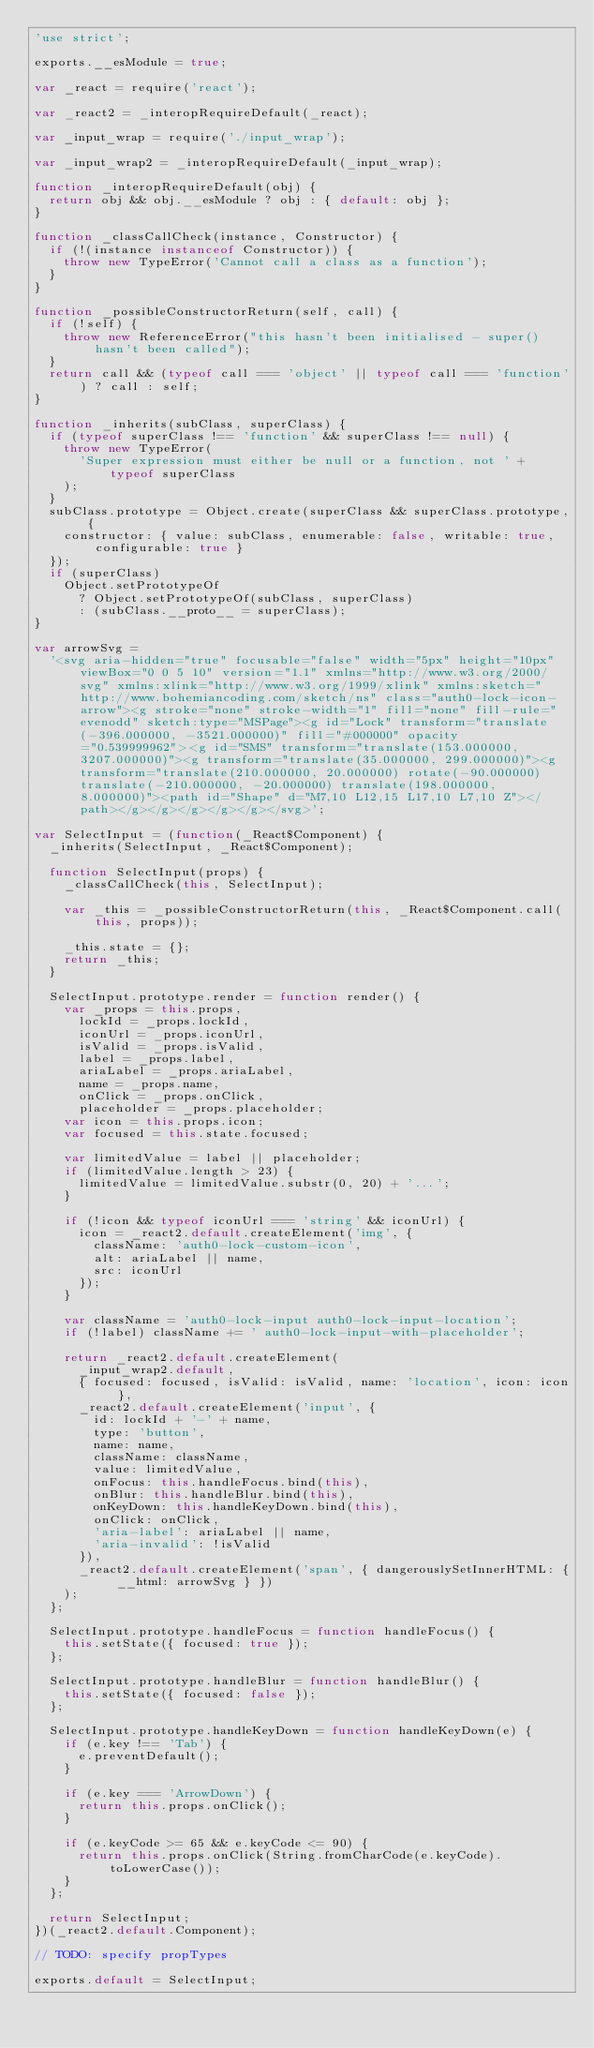Convert code to text. <code><loc_0><loc_0><loc_500><loc_500><_JavaScript_>'use strict';

exports.__esModule = true;

var _react = require('react');

var _react2 = _interopRequireDefault(_react);

var _input_wrap = require('./input_wrap');

var _input_wrap2 = _interopRequireDefault(_input_wrap);

function _interopRequireDefault(obj) {
  return obj && obj.__esModule ? obj : { default: obj };
}

function _classCallCheck(instance, Constructor) {
  if (!(instance instanceof Constructor)) {
    throw new TypeError('Cannot call a class as a function');
  }
}

function _possibleConstructorReturn(self, call) {
  if (!self) {
    throw new ReferenceError("this hasn't been initialised - super() hasn't been called");
  }
  return call && (typeof call === 'object' || typeof call === 'function') ? call : self;
}

function _inherits(subClass, superClass) {
  if (typeof superClass !== 'function' && superClass !== null) {
    throw new TypeError(
      'Super expression must either be null or a function, not ' + typeof superClass
    );
  }
  subClass.prototype = Object.create(superClass && superClass.prototype, {
    constructor: { value: subClass, enumerable: false, writable: true, configurable: true }
  });
  if (superClass)
    Object.setPrototypeOf
      ? Object.setPrototypeOf(subClass, superClass)
      : (subClass.__proto__ = superClass);
}

var arrowSvg =
  '<svg aria-hidden="true" focusable="false" width="5px" height="10px" viewBox="0 0 5 10" version="1.1" xmlns="http://www.w3.org/2000/svg" xmlns:xlink="http://www.w3.org/1999/xlink" xmlns:sketch="http://www.bohemiancoding.com/sketch/ns" class="auth0-lock-icon-arrow"><g stroke="none" stroke-width="1" fill="none" fill-rule="evenodd" sketch:type="MSPage"><g id="Lock" transform="translate(-396.000000, -3521.000000)" fill="#000000" opacity="0.539999962"><g id="SMS" transform="translate(153.000000, 3207.000000)"><g transform="translate(35.000000, 299.000000)"><g transform="translate(210.000000, 20.000000) rotate(-90.000000) translate(-210.000000, -20.000000) translate(198.000000, 8.000000)"><path id="Shape" d="M7,10 L12,15 L17,10 L7,10 Z"></path></g></g></g></g></g></svg>';

var SelectInput = (function(_React$Component) {
  _inherits(SelectInput, _React$Component);

  function SelectInput(props) {
    _classCallCheck(this, SelectInput);

    var _this = _possibleConstructorReturn(this, _React$Component.call(this, props));

    _this.state = {};
    return _this;
  }

  SelectInput.prototype.render = function render() {
    var _props = this.props,
      lockId = _props.lockId,
      iconUrl = _props.iconUrl,
      isValid = _props.isValid,
      label = _props.label,
      ariaLabel = _props.ariaLabel,
      name = _props.name,
      onClick = _props.onClick,
      placeholder = _props.placeholder;
    var icon = this.props.icon;
    var focused = this.state.focused;

    var limitedValue = label || placeholder;
    if (limitedValue.length > 23) {
      limitedValue = limitedValue.substr(0, 20) + '...';
    }

    if (!icon && typeof iconUrl === 'string' && iconUrl) {
      icon = _react2.default.createElement('img', {
        className: 'auth0-lock-custom-icon',
        alt: ariaLabel || name,
        src: iconUrl
      });
    }

    var className = 'auth0-lock-input auth0-lock-input-location';
    if (!label) className += ' auth0-lock-input-with-placeholder';

    return _react2.default.createElement(
      _input_wrap2.default,
      { focused: focused, isValid: isValid, name: 'location', icon: icon },
      _react2.default.createElement('input', {
        id: lockId + '-' + name,
        type: 'button',
        name: name,
        className: className,
        value: limitedValue,
        onFocus: this.handleFocus.bind(this),
        onBlur: this.handleBlur.bind(this),
        onKeyDown: this.handleKeyDown.bind(this),
        onClick: onClick,
        'aria-label': ariaLabel || name,
        'aria-invalid': !isValid
      }),
      _react2.default.createElement('span', { dangerouslySetInnerHTML: { __html: arrowSvg } })
    );
  };

  SelectInput.prototype.handleFocus = function handleFocus() {
    this.setState({ focused: true });
  };

  SelectInput.prototype.handleBlur = function handleBlur() {
    this.setState({ focused: false });
  };

  SelectInput.prototype.handleKeyDown = function handleKeyDown(e) {
    if (e.key !== 'Tab') {
      e.preventDefault();
    }

    if (e.key === 'ArrowDown') {
      return this.props.onClick();
    }

    if (e.keyCode >= 65 && e.keyCode <= 90) {
      return this.props.onClick(String.fromCharCode(e.keyCode).toLowerCase());
    }
  };

  return SelectInput;
})(_react2.default.Component);

// TODO: specify propTypes

exports.default = SelectInput;
</code> 